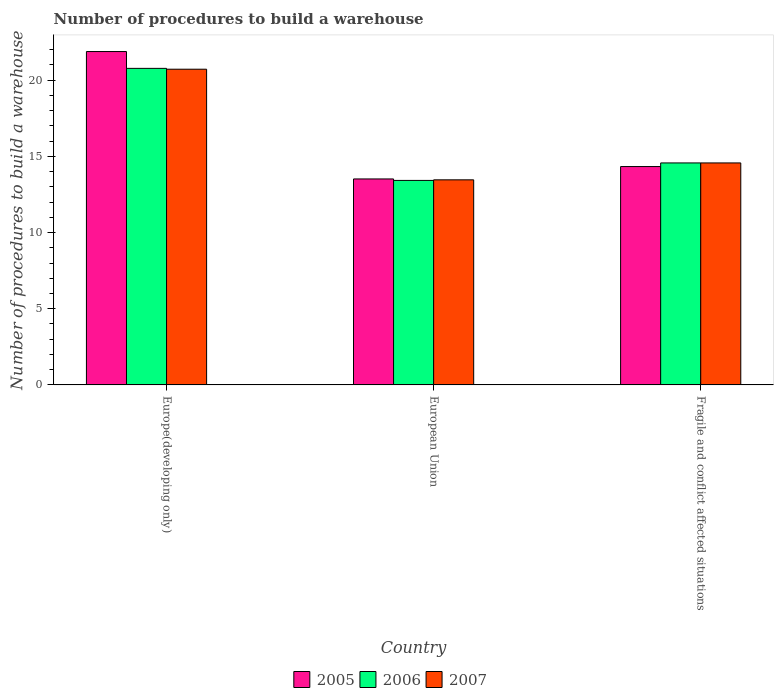How many different coloured bars are there?
Offer a terse response. 3. Are the number of bars per tick equal to the number of legend labels?
Offer a terse response. Yes. How many bars are there on the 2nd tick from the left?
Your answer should be very brief. 3. How many bars are there on the 2nd tick from the right?
Give a very brief answer. 3. What is the label of the 2nd group of bars from the left?
Provide a short and direct response. European Union. In how many cases, is the number of bars for a given country not equal to the number of legend labels?
Ensure brevity in your answer.  0. What is the number of procedures to build a warehouse in in 2005 in Europe(developing only)?
Give a very brief answer. 21.88. Across all countries, what is the maximum number of procedures to build a warehouse in in 2006?
Provide a short and direct response. 20.78. Across all countries, what is the minimum number of procedures to build a warehouse in in 2006?
Ensure brevity in your answer.  13.42. In which country was the number of procedures to build a warehouse in in 2006 maximum?
Your answer should be compact. Europe(developing only). In which country was the number of procedures to build a warehouse in in 2007 minimum?
Give a very brief answer. European Union. What is the total number of procedures to build a warehouse in in 2005 in the graph?
Give a very brief answer. 49.74. What is the difference between the number of procedures to build a warehouse in in 2007 in European Union and that in Fragile and conflict affected situations?
Provide a short and direct response. -1.11. What is the difference between the number of procedures to build a warehouse in in 2007 in Fragile and conflict affected situations and the number of procedures to build a warehouse in in 2005 in European Union?
Offer a terse response. 1.05. What is the average number of procedures to build a warehouse in in 2005 per country?
Provide a short and direct response. 16.58. What is the difference between the number of procedures to build a warehouse in of/in 2005 and number of procedures to build a warehouse in of/in 2006 in Fragile and conflict affected situations?
Make the answer very short. -0.24. What is the ratio of the number of procedures to build a warehouse in in 2005 in Europe(developing only) to that in European Union?
Offer a terse response. 1.62. Is the number of procedures to build a warehouse in in 2005 in European Union less than that in Fragile and conflict affected situations?
Your response must be concise. Yes. Is the difference between the number of procedures to build a warehouse in in 2005 in European Union and Fragile and conflict affected situations greater than the difference between the number of procedures to build a warehouse in in 2006 in European Union and Fragile and conflict affected situations?
Your answer should be compact. Yes. What is the difference between the highest and the second highest number of procedures to build a warehouse in in 2007?
Offer a very short reply. 7.26. What is the difference between the highest and the lowest number of procedures to build a warehouse in in 2006?
Keep it short and to the point. 7.35. Is the sum of the number of procedures to build a warehouse in in 2005 in Europe(developing only) and European Union greater than the maximum number of procedures to build a warehouse in in 2006 across all countries?
Ensure brevity in your answer.  Yes. What does the 1st bar from the right in Europe(developing only) represents?
Give a very brief answer. 2007. How many bars are there?
Your answer should be very brief. 9. Are all the bars in the graph horizontal?
Keep it short and to the point. No. What is the difference between two consecutive major ticks on the Y-axis?
Offer a very short reply. 5. Does the graph contain grids?
Provide a short and direct response. No. Where does the legend appear in the graph?
Offer a very short reply. Bottom center. How are the legend labels stacked?
Offer a terse response. Horizontal. What is the title of the graph?
Give a very brief answer. Number of procedures to build a warehouse. What is the label or title of the Y-axis?
Ensure brevity in your answer.  Number of procedures to build a warehouse. What is the Number of procedures to build a warehouse in 2005 in Europe(developing only)?
Ensure brevity in your answer.  21.88. What is the Number of procedures to build a warehouse in 2006 in Europe(developing only)?
Give a very brief answer. 20.78. What is the Number of procedures to build a warehouse of 2007 in Europe(developing only)?
Make the answer very short. 20.72. What is the Number of procedures to build a warehouse of 2005 in European Union?
Keep it short and to the point. 13.52. What is the Number of procedures to build a warehouse of 2006 in European Union?
Provide a short and direct response. 13.42. What is the Number of procedures to build a warehouse of 2007 in European Union?
Provide a succinct answer. 13.46. What is the Number of procedures to build a warehouse of 2005 in Fragile and conflict affected situations?
Ensure brevity in your answer.  14.33. What is the Number of procedures to build a warehouse in 2006 in Fragile and conflict affected situations?
Provide a succinct answer. 14.57. What is the Number of procedures to build a warehouse of 2007 in Fragile and conflict affected situations?
Make the answer very short. 14.57. Across all countries, what is the maximum Number of procedures to build a warehouse of 2005?
Keep it short and to the point. 21.88. Across all countries, what is the maximum Number of procedures to build a warehouse of 2006?
Keep it short and to the point. 20.78. Across all countries, what is the maximum Number of procedures to build a warehouse in 2007?
Provide a succinct answer. 20.72. Across all countries, what is the minimum Number of procedures to build a warehouse in 2005?
Keep it short and to the point. 13.52. Across all countries, what is the minimum Number of procedures to build a warehouse in 2006?
Provide a short and direct response. 13.42. Across all countries, what is the minimum Number of procedures to build a warehouse of 2007?
Ensure brevity in your answer.  13.46. What is the total Number of procedures to build a warehouse in 2005 in the graph?
Ensure brevity in your answer.  49.74. What is the total Number of procedures to build a warehouse of 2006 in the graph?
Your response must be concise. 48.77. What is the total Number of procedures to build a warehouse of 2007 in the graph?
Keep it short and to the point. 48.76. What is the difference between the Number of procedures to build a warehouse in 2005 in Europe(developing only) and that in European Union?
Offer a very short reply. 8.36. What is the difference between the Number of procedures to build a warehouse of 2006 in Europe(developing only) and that in European Union?
Your answer should be compact. 7.35. What is the difference between the Number of procedures to build a warehouse of 2007 in Europe(developing only) and that in European Union?
Offer a terse response. 7.26. What is the difference between the Number of procedures to build a warehouse in 2005 in Europe(developing only) and that in Fragile and conflict affected situations?
Provide a succinct answer. 7.55. What is the difference between the Number of procedures to build a warehouse of 2006 in Europe(developing only) and that in Fragile and conflict affected situations?
Keep it short and to the point. 6.21. What is the difference between the Number of procedures to build a warehouse of 2007 in Europe(developing only) and that in Fragile and conflict affected situations?
Offer a terse response. 6.15. What is the difference between the Number of procedures to build a warehouse in 2005 in European Union and that in Fragile and conflict affected situations?
Ensure brevity in your answer.  -0.81. What is the difference between the Number of procedures to build a warehouse of 2006 in European Union and that in Fragile and conflict affected situations?
Keep it short and to the point. -1.15. What is the difference between the Number of procedures to build a warehouse in 2007 in European Union and that in Fragile and conflict affected situations?
Provide a succinct answer. -1.11. What is the difference between the Number of procedures to build a warehouse of 2005 in Europe(developing only) and the Number of procedures to build a warehouse of 2006 in European Union?
Your answer should be very brief. 8.46. What is the difference between the Number of procedures to build a warehouse of 2005 in Europe(developing only) and the Number of procedures to build a warehouse of 2007 in European Union?
Offer a very short reply. 8.42. What is the difference between the Number of procedures to build a warehouse in 2006 in Europe(developing only) and the Number of procedures to build a warehouse in 2007 in European Union?
Your answer should be compact. 7.32. What is the difference between the Number of procedures to build a warehouse in 2005 in Europe(developing only) and the Number of procedures to build a warehouse in 2006 in Fragile and conflict affected situations?
Your answer should be very brief. 7.31. What is the difference between the Number of procedures to build a warehouse in 2005 in Europe(developing only) and the Number of procedures to build a warehouse in 2007 in Fragile and conflict affected situations?
Make the answer very short. 7.31. What is the difference between the Number of procedures to build a warehouse of 2006 in Europe(developing only) and the Number of procedures to build a warehouse of 2007 in Fragile and conflict affected situations?
Make the answer very short. 6.21. What is the difference between the Number of procedures to build a warehouse in 2005 in European Union and the Number of procedures to build a warehouse in 2006 in Fragile and conflict affected situations?
Keep it short and to the point. -1.05. What is the difference between the Number of procedures to build a warehouse in 2005 in European Union and the Number of procedures to build a warehouse in 2007 in Fragile and conflict affected situations?
Ensure brevity in your answer.  -1.05. What is the difference between the Number of procedures to build a warehouse of 2006 in European Union and the Number of procedures to build a warehouse of 2007 in Fragile and conflict affected situations?
Make the answer very short. -1.15. What is the average Number of procedures to build a warehouse in 2005 per country?
Ensure brevity in your answer.  16.58. What is the average Number of procedures to build a warehouse in 2006 per country?
Offer a terse response. 16.26. What is the average Number of procedures to build a warehouse of 2007 per country?
Your answer should be very brief. 16.25. What is the difference between the Number of procedures to build a warehouse of 2005 and Number of procedures to build a warehouse of 2006 in Europe(developing only)?
Give a very brief answer. 1.1. What is the difference between the Number of procedures to build a warehouse in 2005 and Number of procedures to build a warehouse in 2007 in Europe(developing only)?
Give a very brief answer. 1.16. What is the difference between the Number of procedures to build a warehouse in 2006 and Number of procedures to build a warehouse in 2007 in Europe(developing only)?
Give a very brief answer. 0.06. What is the difference between the Number of procedures to build a warehouse in 2005 and Number of procedures to build a warehouse in 2006 in European Union?
Offer a very short reply. 0.1. What is the difference between the Number of procedures to build a warehouse in 2005 and Number of procedures to build a warehouse in 2007 in European Union?
Provide a succinct answer. 0.06. What is the difference between the Number of procedures to build a warehouse in 2006 and Number of procedures to build a warehouse in 2007 in European Union?
Offer a very short reply. -0.04. What is the difference between the Number of procedures to build a warehouse in 2005 and Number of procedures to build a warehouse in 2006 in Fragile and conflict affected situations?
Make the answer very short. -0.24. What is the difference between the Number of procedures to build a warehouse of 2005 and Number of procedures to build a warehouse of 2007 in Fragile and conflict affected situations?
Offer a very short reply. -0.24. What is the ratio of the Number of procedures to build a warehouse in 2005 in Europe(developing only) to that in European Union?
Provide a short and direct response. 1.62. What is the ratio of the Number of procedures to build a warehouse in 2006 in Europe(developing only) to that in European Union?
Offer a terse response. 1.55. What is the ratio of the Number of procedures to build a warehouse of 2007 in Europe(developing only) to that in European Union?
Keep it short and to the point. 1.54. What is the ratio of the Number of procedures to build a warehouse of 2005 in Europe(developing only) to that in Fragile and conflict affected situations?
Your answer should be compact. 1.53. What is the ratio of the Number of procedures to build a warehouse in 2006 in Europe(developing only) to that in Fragile and conflict affected situations?
Make the answer very short. 1.43. What is the ratio of the Number of procedures to build a warehouse in 2007 in Europe(developing only) to that in Fragile and conflict affected situations?
Make the answer very short. 1.42. What is the ratio of the Number of procedures to build a warehouse of 2005 in European Union to that in Fragile and conflict affected situations?
Offer a terse response. 0.94. What is the ratio of the Number of procedures to build a warehouse of 2006 in European Union to that in Fragile and conflict affected situations?
Ensure brevity in your answer.  0.92. What is the ratio of the Number of procedures to build a warehouse in 2007 in European Union to that in Fragile and conflict affected situations?
Make the answer very short. 0.92. What is the difference between the highest and the second highest Number of procedures to build a warehouse of 2005?
Give a very brief answer. 7.55. What is the difference between the highest and the second highest Number of procedures to build a warehouse in 2006?
Provide a short and direct response. 6.21. What is the difference between the highest and the second highest Number of procedures to build a warehouse of 2007?
Provide a succinct answer. 6.15. What is the difference between the highest and the lowest Number of procedures to build a warehouse in 2005?
Give a very brief answer. 8.36. What is the difference between the highest and the lowest Number of procedures to build a warehouse of 2006?
Your response must be concise. 7.35. What is the difference between the highest and the lowest Number of procedures to build a warehouse in 2007?
Make the answer very short. 7.26. 